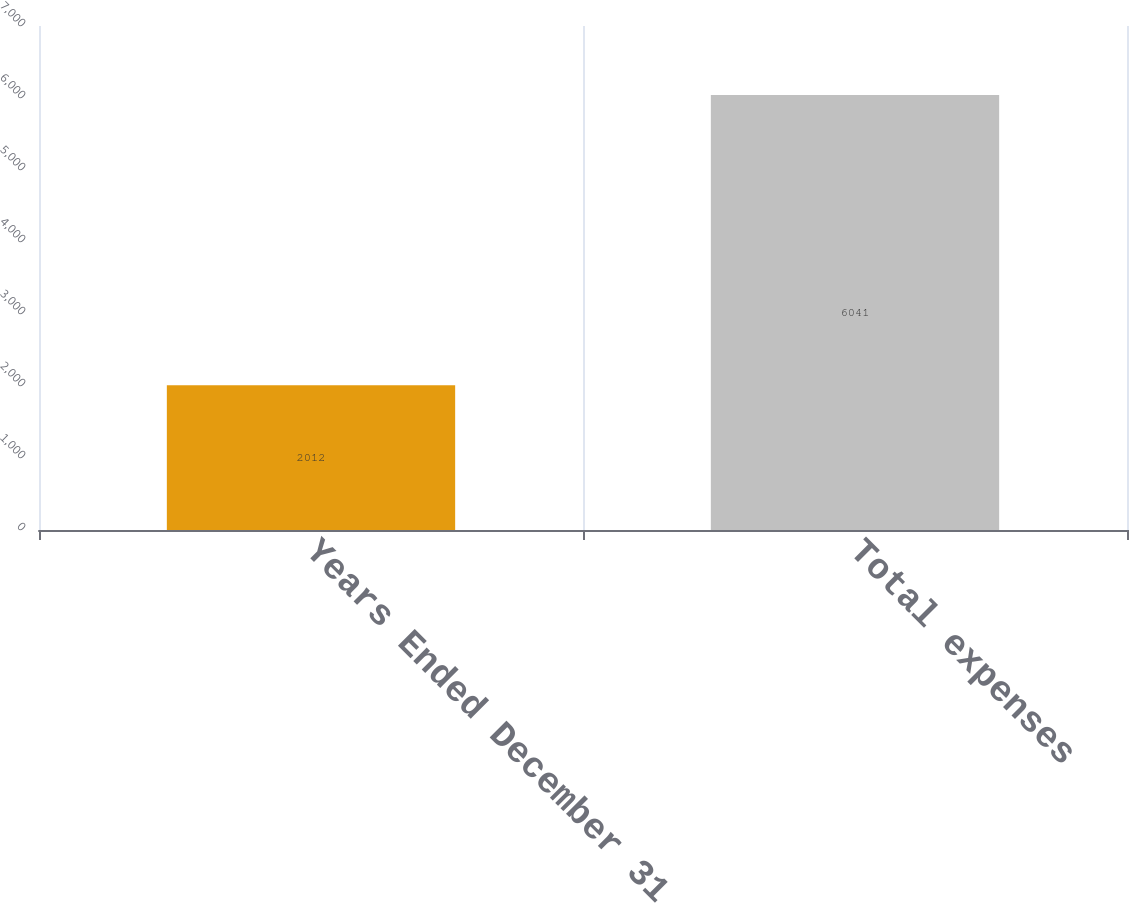<chart> <loc_0><loc_0><loc_500><loc_500><bar_chart><fcel>Years Ended December 31<fcel>Total expenses<nl><fcel>2012<fcel>6041<nl></chart> 